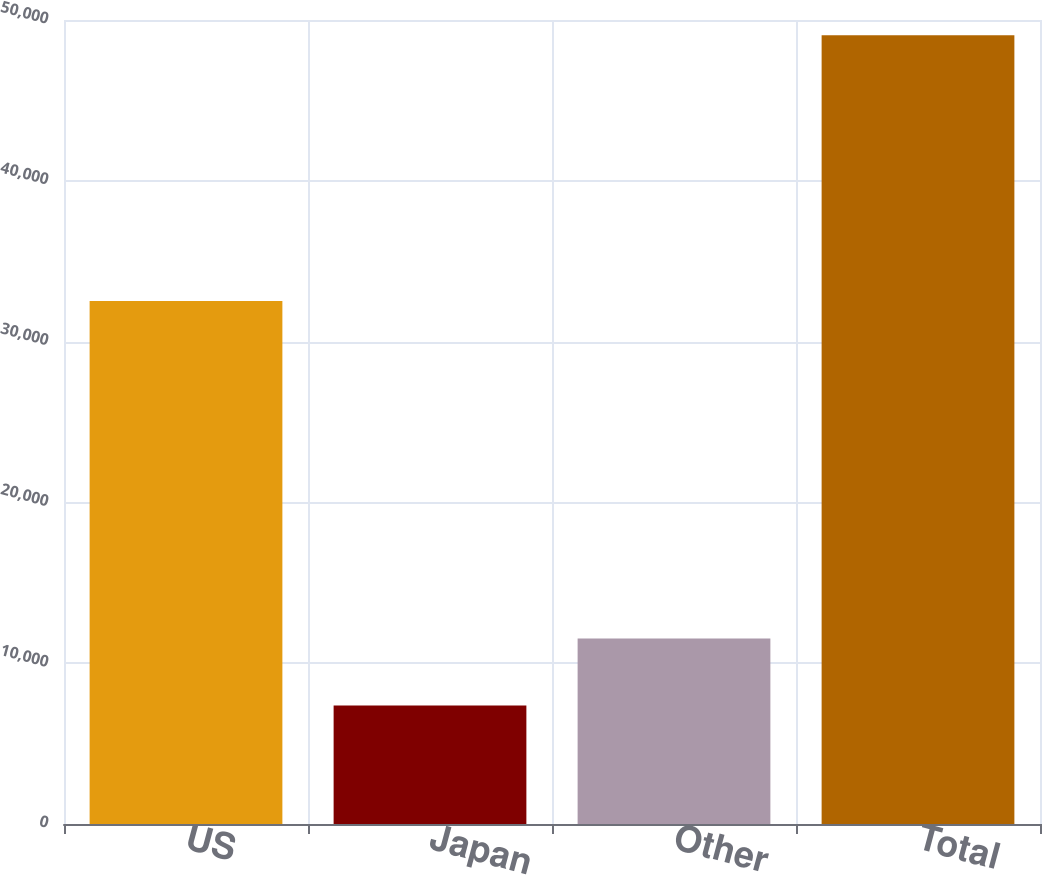<chart> <loc_0><loc_0><loc_500><loc_500><bar_chart><fcel>US<fcel>Japan<fcel>Other<fcel>Total<nl><fcel>32529<fcel>7373<fcel>11540.2<fcel>49045<nl></chart> 